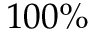<formula> <loc_0><loc_0><loc_500><loc_500>1 0 0 \%</formula> 